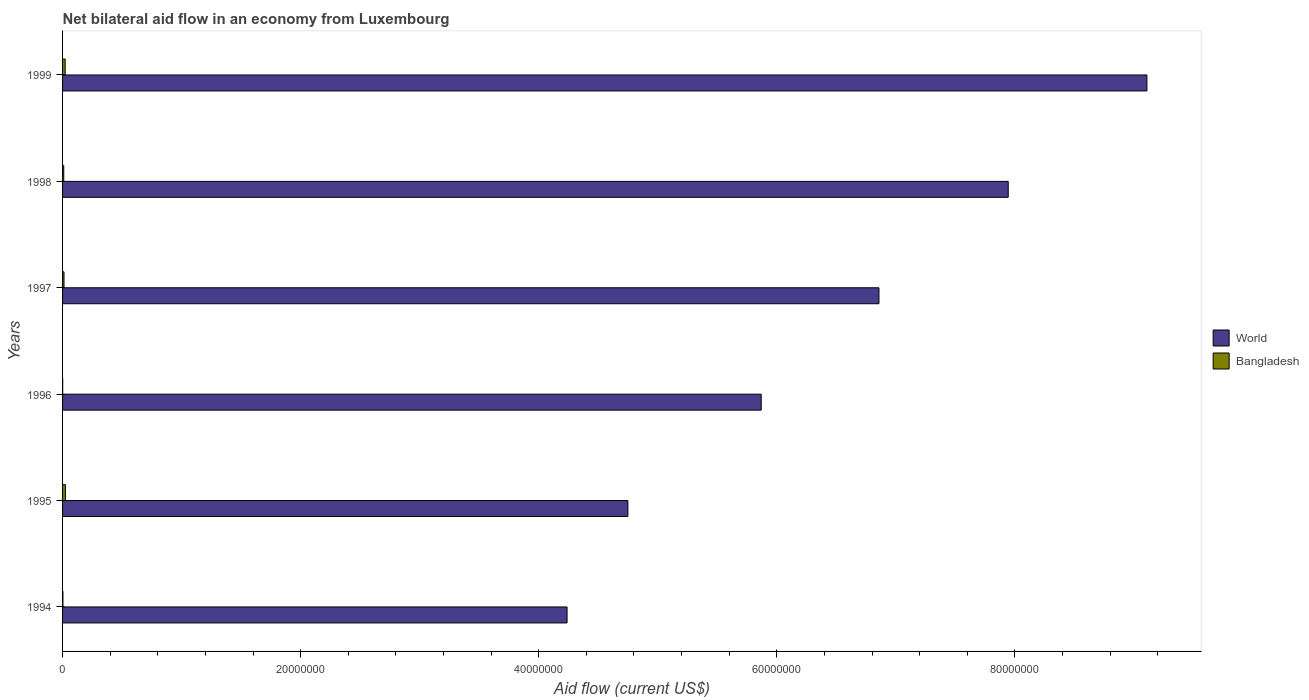How many groups of bars are there?
Make the answer very short. 6. Are the number of bars on each tick of the Y-axis equal?
Make the answer very short. Yes. How many bars are there on the 6th tick from the top?
Offer a very short reply. 2. How many bars are there on the 3rd tick from the bottom?
Ensure brevity in your answer.  2. What is the label of the 4th group of bars from the top?
Your answer should be compact. 1996. What is the net bilateral aid flow in Bangladesh in 1996?
Offer a very short reply. 10000. Across all years, what is the minimum net bilateral aid flow in World?
Provide a succinct answer. 4.24e+07. In which year was the net bilateral aid flow in Bangladesh maximum?
Your response must be concise. 1995. What is the total net bilateral aid flow in World in the graph?
Make the answer very short. 3.88e+08. What is the difference between the net bilateral aid flow in World in 1994 and that in 1999?
Your answer should be very brief. -4.87e+07. What is the difference between the net bilateral aid flow in World in 1995 and the net bilateral aid flow in Bangladesh in 1997?
Offer a terse response. 4.74e+07. In the year 1995, what is the difference between the net bilateral aid flow in World and net bilateral aid flow in Bangladesh?
Give a very brief answer. 4.72e+07. In how many years, is the net bilateral aid flow in World greater than 20000000 US$?
Keep it short and to the point. 6. What is the ratio of the net bilateral aid flow in Bangladesh in 1994 to that in 1998?
Offer a terse response. 0.3. What is the difference between the highest and the second highest net bilateral aid flow in World?
Your answer should be very brief. 1.16e+07. What is the difference between the highest and the lowest net bilateral aid flow in Bangladesh?
Provide a succinct answer. 2.30e+05. In how many years, is the net bilateral aid flow in Bangladesh greater than the average net bilateral aid flow in Bangladesh taken over all years?
Provide a short and direct response. 2. Is the sum of the net bilateral aid flow in Bangladesh in 1994 and 1996 greater than the maximum net bilateral aid flow in World across all years?
Offer a very short reply. No. What does the 2nd bar from the bottom in 1994 represents?
Provide a short and direct response. Bangladesh. How many years are there in the graph?
Give a very brief answer. 6. What is the difference between two consecutive major ticks on the X-axis?
Offer a terse response. 2.00e+07. Does the graph contain any zero values?
Offer a very short reply. No. Does the graph contain grids?
Provide a short and direct response. No. Where does the legend appear in the graph?
Offer a terse response. Center right. How many legend labels are there?
Make the answer very short. 2. How are the legend labels stacked?
Your answer should be compact. Vertical. What is the title of the graph?
Provide a succinct answer. Net bilateral aid flow in an economy from Luxembourg. What is the Aid flow (current US$) in World in 1994?
Make the answer very short. 4.24e+07. What is the Aid flow (current US$) in World in 1995?
Your answer should be very brief. 4.75e+07. What is the Aid flow (current US$) in World in 1996?
Your answer should be very brief. 5.87e+07. What is the Aid flow (current US$) of Bangladesh in 1996?
Provide a short and direct response. 10000. What is the Aid flow (current US$) in World in 1997?
Offer a terse response. 6.86e+07. What is the Aid flow (current US$) of World in 1998?
Give a very brief answer. 7.94e+07. What is the Aid flow (current US$) of World in 1999?
Your response must be concise. 9.11e+07. Across all years, what is the maximum Aid flow (current US$) in World?
Provide a succinct answer. 9.11e+07. Across all years, what is the minimum Aid flow (current US$) of World?
Give a very brief answer. 4.24e+07. What is the total Aid flow (current US$) of World in the graph?
Provide a short and direct response. 3.88e+08. What is the total Aid flow (current US$) of Bangladesh in the graph?
Keep it short and to the point. 7.20e+05. What is the difference between the Aid flow (current US$) of World in 1994 and that in 1995?
Offer a terse response. -5.11e+06. What is the difference between the Aid flow (current US$) of Bangladesh in 1994 and that in 1995?
Provide a succinct answer. -2.10e+05. What is the difference between the Aid flow (current US$) in World in 1994 and that in 1996?
Provide a succinct answer. -1.63e+07. What is the difference between the Aid flow (current US$) of Bangladesh in 1994 and that in 1996?
Your answer should be compact. 2.00e+04. What is the difference between the Aid flow (current US$) in World in 1994 and that in 1997?
Provide a short and direct response. -2.62e+07. What is the difference between the Aid flow (current US$) of Bangladesh in 1994 and that in 1997?
Provide a short and direct response. -9.00e+04. What is the difference between the Aid flow (current US$) of World in 1994 and that in 1998?
Give a very brief answer. -3.71e+07. What is the difference between the Aid flow (current US$) of World in 1994 and that in 1999?
Keep it short and to the point. -4.87e+07. What is the difference between the Aid flow (current US$) in World in 1995 and that in 1996?
Offer a very short reply. -1.12e+07. What is the difference between the Aid flow (current US$) of Bangladesh in 1995 and that in 1996?
Offer a terse response. 2.30e+05. What is the difference between the Aid flow (current US$) in World in 1995 and that in 1997?
Your response must be concise. -2.11e+07. What is the difference between the Aid flow (current US$) in Bangladesh in 1995 and that in 1997?
Give a very brief answer. 1.20e+05. What is the difference between the Aid flow (current US$) of World in 1995 and that in 1998?
Your answer should be very brief. -3.20e+07. What is the difference between the Aid flow (current US$) of World in 1995 and that in 1999?
Give a very brief answer. -4.36e+07. What is the difference between the Aid flow (current US$) of World in 1996 and that in 1997?
Make the answer very short. -9.89e+06. What is the difference between the Aid flow (current US$) in World in 1996 and that in 1998?
Your answer should be compact. -2.08e+07. What is the difference between the Aid flow (current US$) in World in 1996 and that in 1999?
Offer a terse response. -3.24e+07. What is the difference between the Aid flow (current US$) of World in 1997 and that in 1998?
Provide a short and direct response. -1.09e+07. What is the difference between the Aid flow (current US$) of World in 1997 and that in 1999?
Offer a terse response. -2.25e+07. What is the difference between the Aid flow (current US$) in World in 1998 and that in 1999?
Ensure brevity in your answer.  -1.16e+07. What is the difference between the Aid flow (current US$) of Bangladesh in 1998 and that in 1999?
Give a very brief answer. -1.20e+05. What is the difference between the Aid flow (current US$) in World in 1994 and the Aid flow (current US$) in Bangladesh in 1995?
Your answer should be compact. 4.21e+07. What is the difference between the Aid flow (current US$) of World in 1994 and the Aid flow (current US$) of Bangladesh in 1996?
Provide a short and direct response. 4.24e+07. What is the difference between the Aid flow (current US$) in World in 1994 and the Aid flow (current US$) in Bangladesh in 1997?
Give a very brief answer. 4.23e+07. What is the difference between the Aid flow (current US$) of World in 1994 and the Aid flow (current US$) of Bangladesh in 1998?
Offer a very short reply. 4.23e+07. What is the difference between the Aid flow (current US$) in World in 1994 and the Aid flow (current US$) in Bangladesh in 1999?
Provide a short and direct response. 4.22e+07. What is the difference between the Aid flow (current US$) in World in 1995 and the Aid flow (current US$) in Bangladesh in 1996?
Offer a very short reply. 4.75e+07. What is the difference between the Aid flow (current US$) of World in 1995 and the Aid flow (current US$) of Bangladesh in 1997?
Offer a very short reply. 4.74e+07. What is the difference between the Aid flow (current US$) of World in 1995 and the Aid flow (current US$) of Bangladesh in 1998?
Make the answer very short. 4.74e+07. What is the difference between the Aid flow (current US$) of World in 1995 and the Aid flow (current US$) of Bangladesh in 1999?
Give a very brief answer. 4.73e+07. What is the difference between the Aid flow (current US$) in World in 1996 and the Aid flow (current US$) in Bangladesh in 1997?
Offer a terse response. 5.86e+07. What is the difference between the Aid flow (current US$) of World in 1996 and the Aid flow (current US$) of Bangladesh in 1998?
Your answer should be compact. 5.86e+07. What is the difference between the Aid flow (current US$) of World in 1996 and the Aid flow (current US$) of Bangladesh in 1999?
Provide a short and direct response. 5.85e+07. What is the difference between the Aid flow (current US$) of World in 1997 and the Aid flow (current US$) of Bangladesh in 1998?
Your response must be concise. 6.85e+07. What is the difference between the Aid flow (current US$) in World in 1997 and the Aid flow (current US$) in Bangladesh in 1999?
Offer a very short reply. 6.84e+07. What is the difference between the Aid flow (current US$) in World in 1998 and the Aid flow (current US$) in Bangladesh in 1999?
Give a very brief answer. 7.92e+07. What is the average Aid flow (current US$) in World per year?
Ensure brevity in your answer.  6.46e+07. What is the average Aid flow (current US$) in Bangladesh per year?
Make the answer very short. 1.20e+05. In the year 1994, what is the difference between the Aid flow (current US$) in World and Aid flow (current US$) in Bangladesh?
Give a very brief answer. 4.24e+07. In the year 1995, what is the difference between the Aid flow (current US$) in World and Aid flow (current US$) in Bangladesh?
Offer a very short reply. 4.72e+07. In the year 1996, what is the difference between the Aid flow (current US$) of World and Aid flow (current US$) of Bangladesh?
Your answer should be very brief. 5.87e+07. In the year 1997, what is the difference between the Aid flow (current US$) in World and Aid flow (current US$) in Bangladesh?
Your answer should be very brief. 6.85e+07. In the year 1998, what is the difference between the Aid flow (current US$) in World and Aid flow (current US$) in Bangladesh?
Your answer should be very brief. 7.93e+07. In the year 1999, what is the difference between the Aid flow (current US$) of World and Aid flow (current US$) of Bangladesh?
Provide a succinct answer. 9.09e+07. What is the ratio of the Aid flow (current US$) in World in 1994 to that in 1995?
Provide a short and direct response. 0.89. What is the ratio of the Aid flow (current US$) of World in 1994 to that in 1996?
Ensure brevity in your answer.  0.72. What is the ratio of the Aid flow (current US$) in World in 1994 to that in 1997?
Your answer should be very brief. 0.62. What is the ratio of the Aid flow (current US$) in Bangladesh in 1994 to that in 1997?
Keep it short and to the point. 0.25. What is the ratio of the Aid flow (current US$) in World in 1994 to that in 1998?
Ensure brevity in your answer.  0.53. What is the ratio of the Aid flow (current US$) in World in 1994 to that in 1999?
Offer a very short reply. 0.47. What is the ratio of the Aid flow (current US$) in Bangladesh in 1994 to that in 1999?
Offer a terse response. 0.14. What is the ratio of the Aid flow (current US$) in World in 1995 to that in 1996?
Provide a succinct answer. 0.81. What is the ratio of the Aid flow (current US$) in Bangladesh in 1995 to that in 1996?
Ensure brevity in your answer.  24. What is the ratio of the Aid flow (current US$) of World in 1995 to that in 1997?
Ensure brevity in your answer.  0.69. What is the ratio of the Aid flow (current US$) of Bangladesh in 1995 to that in 1997?
Give a very brief answer. 2. What is the ratio of the Aid flow (current US$) in World in 1995 to that in 1998?
Provide a succinct answer. 0.6. What is the ratio of the Aid flow (current US$) of Bangladesh in 1995 to that in 1998?
Offer a very short reply. 2.4. What is the ratio of the Aid flow (current US$) in World in 1995 to that in 1999?
Provide a short and direct response. 0.52. What is the ratio of the Aid flow (current US$) in Bangladesh in 1995 to that in 1999?
Offer a terse response. 1.09. What is the ratio of the Aid flow (current US$) in World in 1996 to that in 1997?
Give a very brief answer. 0.86. What is the ratio of the Aid flow (current US$) in Bangladesh in 1996 to that in 1997?
Your response must be concise. 0.08. What is the ratio of the Aid flow (current US$) of World in 1996 to that in 1998?
Your response must be concise. 0.74. What is the ratio of the Aid flow (current US$) of Bangladesh in 1996 to that in 1998?
Give a very brief answer. 0.1. What is the ratio of the Aid flow (current US$) of World in 1996 to that in 1999?
Provide a succinct answer. 0.64. What is the ratio of the Aid flow (current US$) in Bangladesh in 1996 to that in 1999?
Provide a succinct answer. 0.05. What is the ratio of the Aid flow (current US$) of World in 1997 to that in 1998?
Provide a short and direct response. 0.86. What is the ratio of the Aid flow (current US$) of Bangladesh in 1997 to that in 1998?
Provide a short and direct response. 1.2. What is the ratio of the Aid flow (current US$) of World in 1997 to that in 1999?
Keep it short and to the point. 0.75. What is the ratio of the Aid flow (current US$) of Bangladesh in 1997 to that in 1999?
Give a very brief answer. 0.55. What is the ratio of the Aid flow (current US$) of World in 1998 to that in 1999?
Make the answer very short. 0.87. What is the ratio of the Aid flow (current US$) in Bangladesh in 1998 to that in 1999?
Provide a short and direct response. 0.45. What is the difference between the highest and the second highest Aid flow (current US$) in World?
Provide a succinct answer. 1.16e+07. What is the difference between the highest and the second highest Aid flow (current US$) of Bangladesh?
Your answer should be very brief. 2.00e+04. What is the difference between the highest and the lowest Aid flow (current US$) in World?
Make the answer very short. 4.87e+07. 